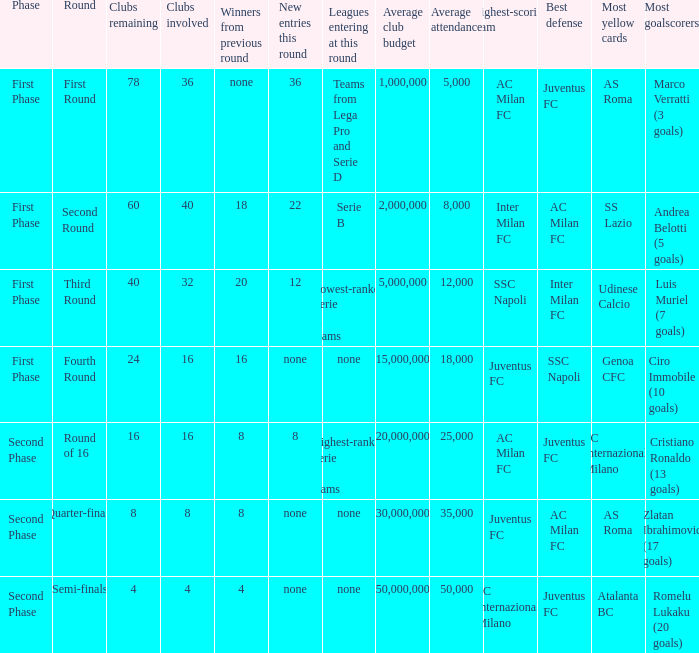During the first phase portion of phase and having 16 clubs involved; what would you find for the winners from previous round? 16.0. 